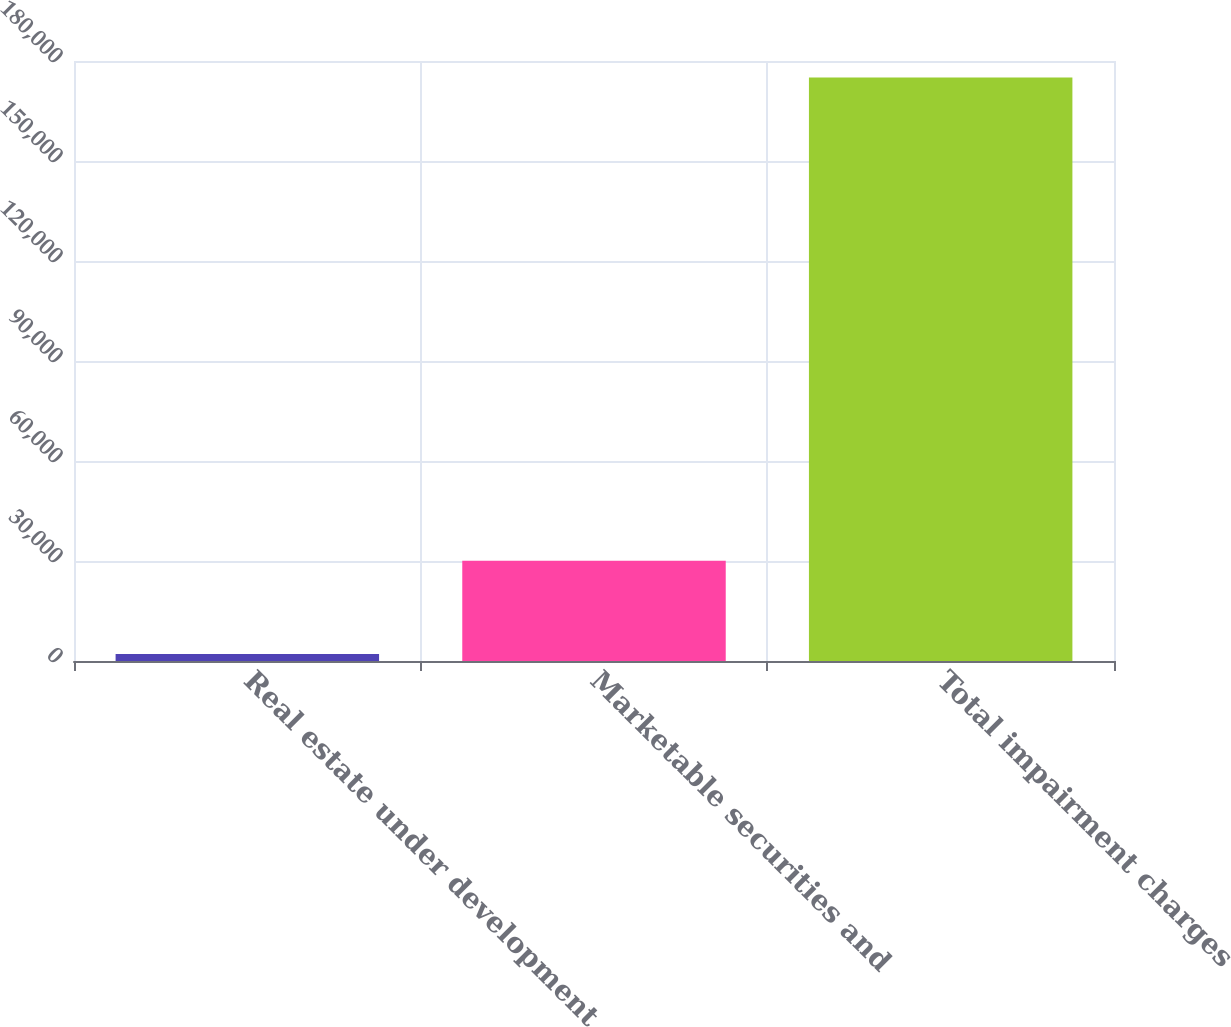Convert chart to OTSL. <chart><loc_0><loc_0><loc_500><loc_500><bar_chart><fcel>Real estate under development<fcel>Marketable securities and<fcel>Total impairment charges<nl><fcel>2100<fcel>30050<fcel>175087<nl></chart> 